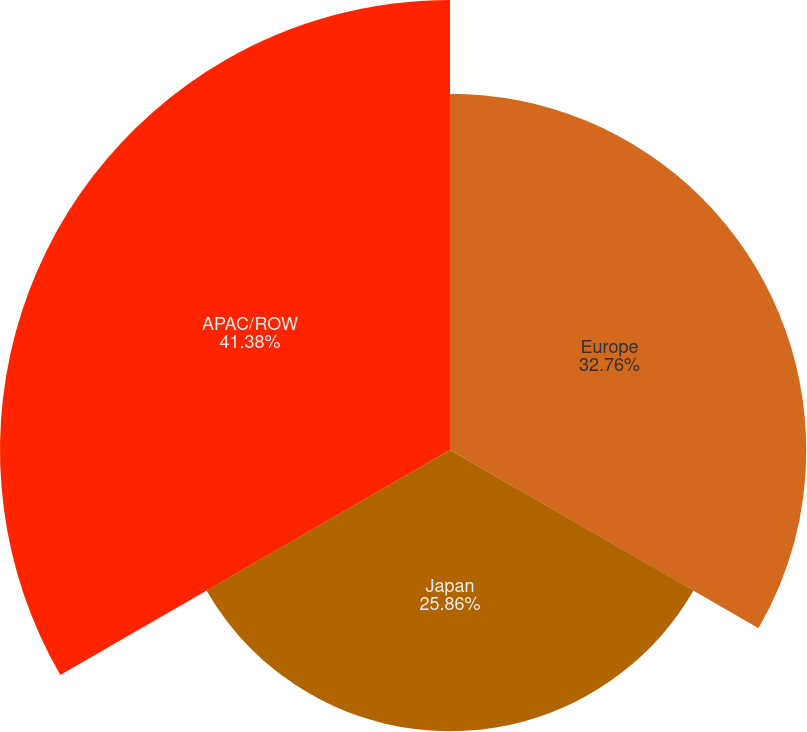<chart> <loc_0><loc_0><loc_500><loc_500><pie_chart><fcel>Europe<fcel>Japan<fcel>APAC/ROW<nl><fcel>32.76%<fcel>25.86%<fcel>41.38%<nl></chart> 